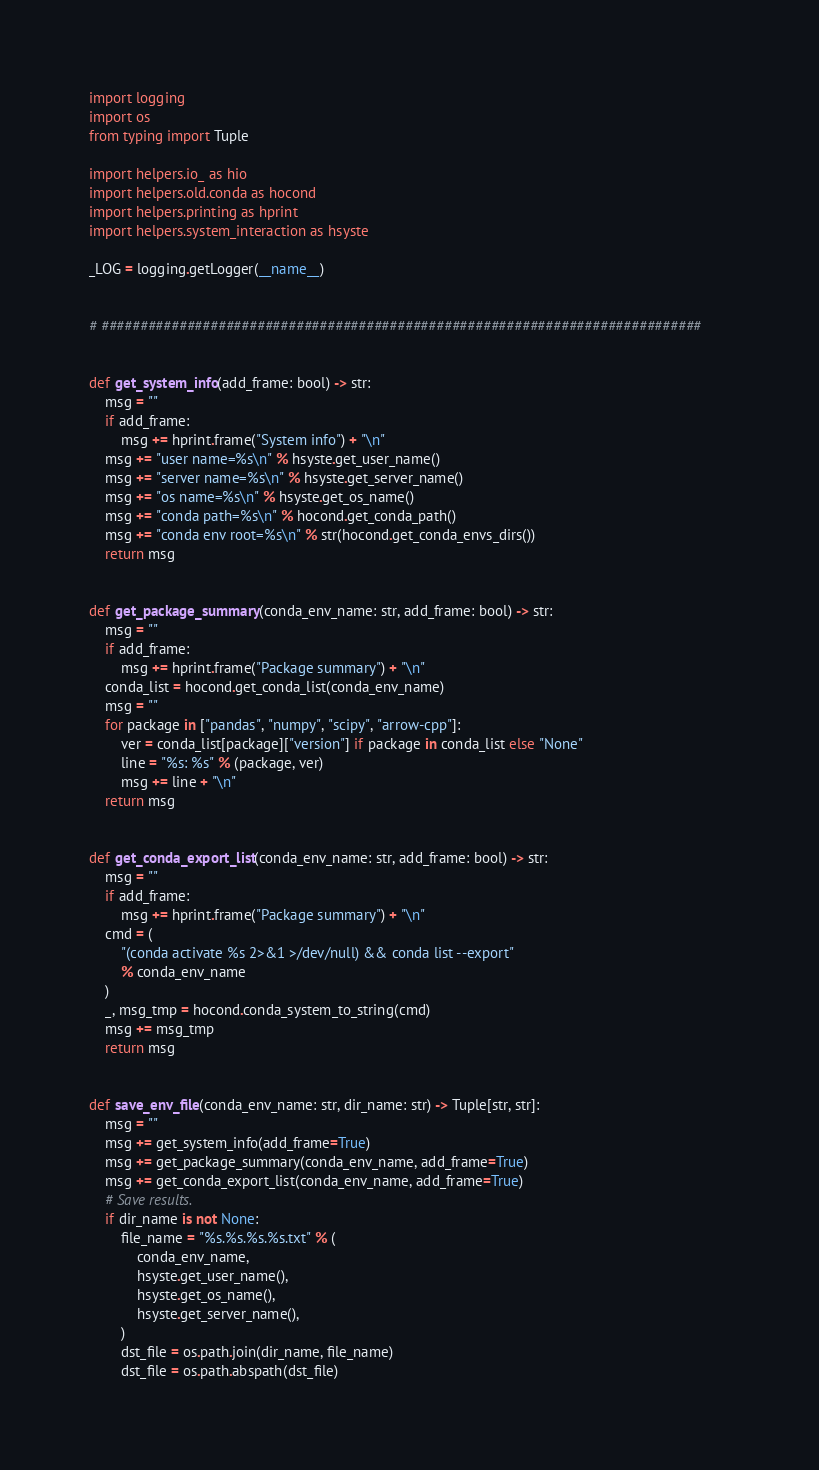Convert code to text. <code><loc_0><loc_0><loc_500><loc_500><_Python_>import logging
import os
from typing import Tuple

import helpers.io_ as hio
import helpers.old.conda as hocond
import helpers.printing as hprint
import helpers.system_interaction as hsyste

_LOG = logging.getLogger(__name__)


# #############################################################################


def get_system_info(add_frame: bool) -> str:
    msg = ""
    if add_frame:
        msg += hprint.frame("System info") + "\n"
    msg += "user name=%s\n" % hsyste.get_user_name()
    msg += "server name=%s\n" % hsyste.get_server_name()
    msg += "os name=%s\n" % hsyste.get_os_name()
    msg += "conda path=%s\n" % hocond.get_conda_path()
    msg += "conda env root=%s\n" % str(hocond.get_conda_envs_dirs())
    return msg


def get_package_summary(conda_env_name: str, add_frame: bool) -> str:
    msg = ""
    if add_frame:
        msg += hprint.frame("Package summary") + "\n"
    conda_list = hocond.get_conda_list(conda_env_name)
    msg = ""
    for package in ["pandas", "numpy", "scipy", "arrow-cpp"]:
        ver = conda_list[package]["version"] if package in conda_list else "None"
        line = "%s: %s" % (package, ver)
        msg += line + "\n"
    return msg


def get_conda_export_list(conda_env_name: str, add_frame: bool) -> str:
    msg = ""
    if add_frame:
        msg += hprint.frame("Package summary") + "\n"
    cmd = (
        "(conda activate %s 2>&1 >/dev/null) && conda list --export"
        % conda_env_name
    )
    _, msg_tmp = hocond.conda_system_to_string(cmd)
    msg += msg_tmp
    return msg


def save_env_file(conda_env_name: str, dir_name: str) -> Tuple[str, str]:
    msg = ""
    msg += get_system_info(add_frame=True)
    msg += get_package_summary(conda_env_name, add_frame=True)
    msg += get_conda_export_list(conda_env_name, add_frame=True)
    # Save results.
    if dir_name is not None:
        file_name = "%s.%s.%s.%s.txt" % (
            conda_env_name,
            hsyste.get_user_name(),
            hsyste.get_os_name(),
            hsyste.get_server_name(),
        )
        dst_file = os.path.join(dir_name, file_name)
        dst_file = os.path.abspath(dst_file)</code> 